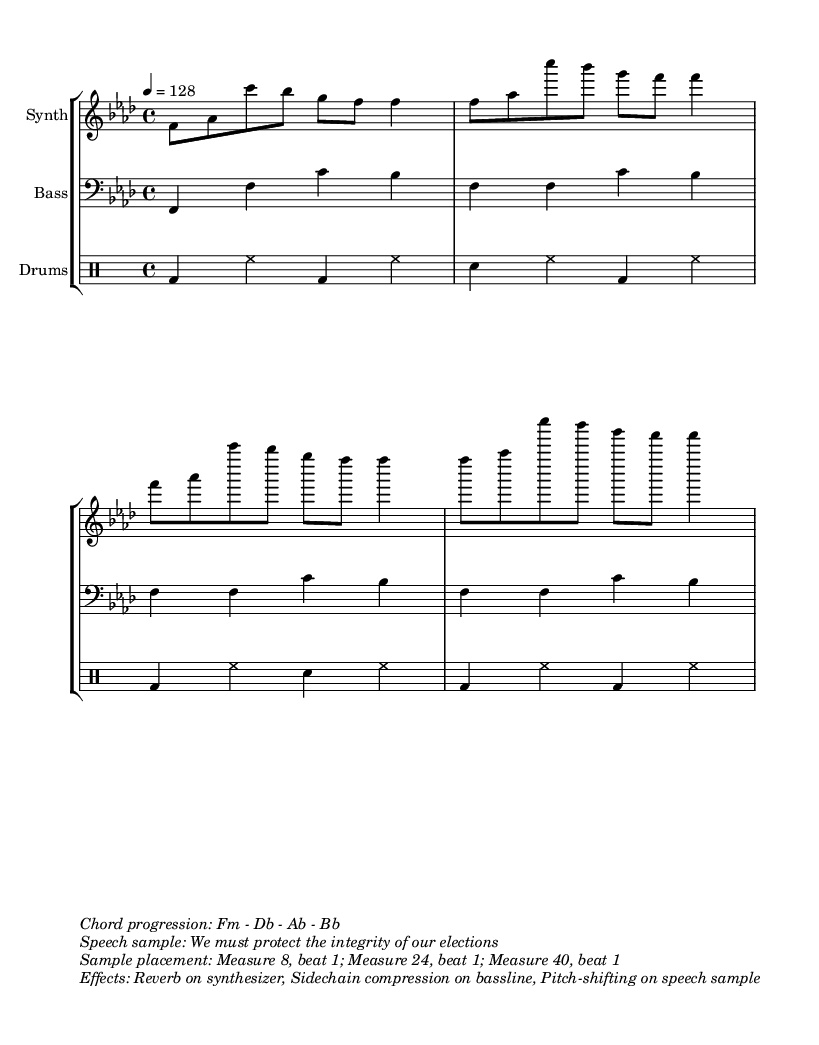What is the key signature of this music? The key signature is indicated after the clef. In this piece, it shows one flat which corresponds to F minor.
Answer: F minor What is the time signature of this music? The time signature is displayed at the beginning of the staff. Here, it is noted as 4/4, meaning four beats per measure with a quarter note receiving one beat.
Answer: 4/4 What is the tempo marking of the music? The tempo marking is found at the beginning of the score, indicating the speed of the piece. In this score, it is marked as 128 beats per minute.
Answer: 128 How many measures are there in total? Counting the number of repetitions and patterns in the music, we can determine that there are a total of 32 measures. Each repeat of the structure contributes to the total.
Answer: 32 What is the chord progression used in this piece? The chord progression is indicated in the markup section, detailing the sequence of chords played throughout the piece. It is specifically listed as F minor to D flat to A flat to B flat.
Answer: Fm - Db - Ab - Bb At which measure does the speech sample begin? The speech sample placement is clearly stated in the markup section of the score, indicating that it begins at measure 8. This is where the speech is first incorporated into the music.
Answer: Measure 8 